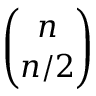Convert formula to latex. <formula><loc_0><loc_0><loc_500><loc_500>\binom { n } { n / 2 }</formula> 